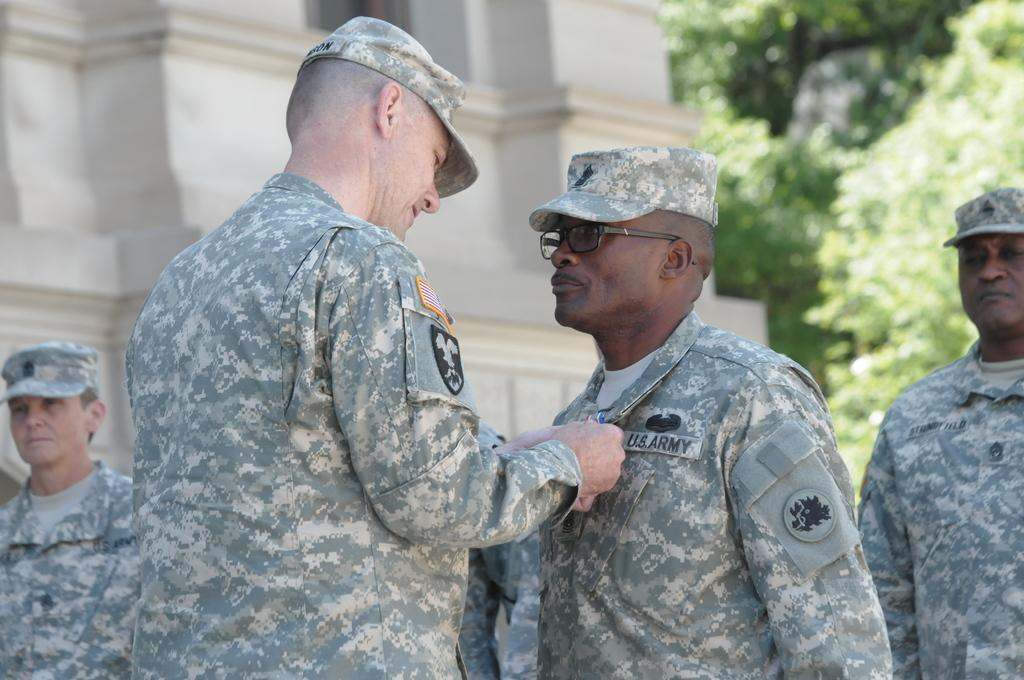What is the main subject of the image? There is a man standing in the image. What can be seen in the background of the image? There are trees and a building in the background of the image. How many suns are visible in the image? There are no suns visible in the image. What point is the man trying to make in the image? The image does not convey any specific point or message, as it only shows a man standing with trees and a building in the background. 